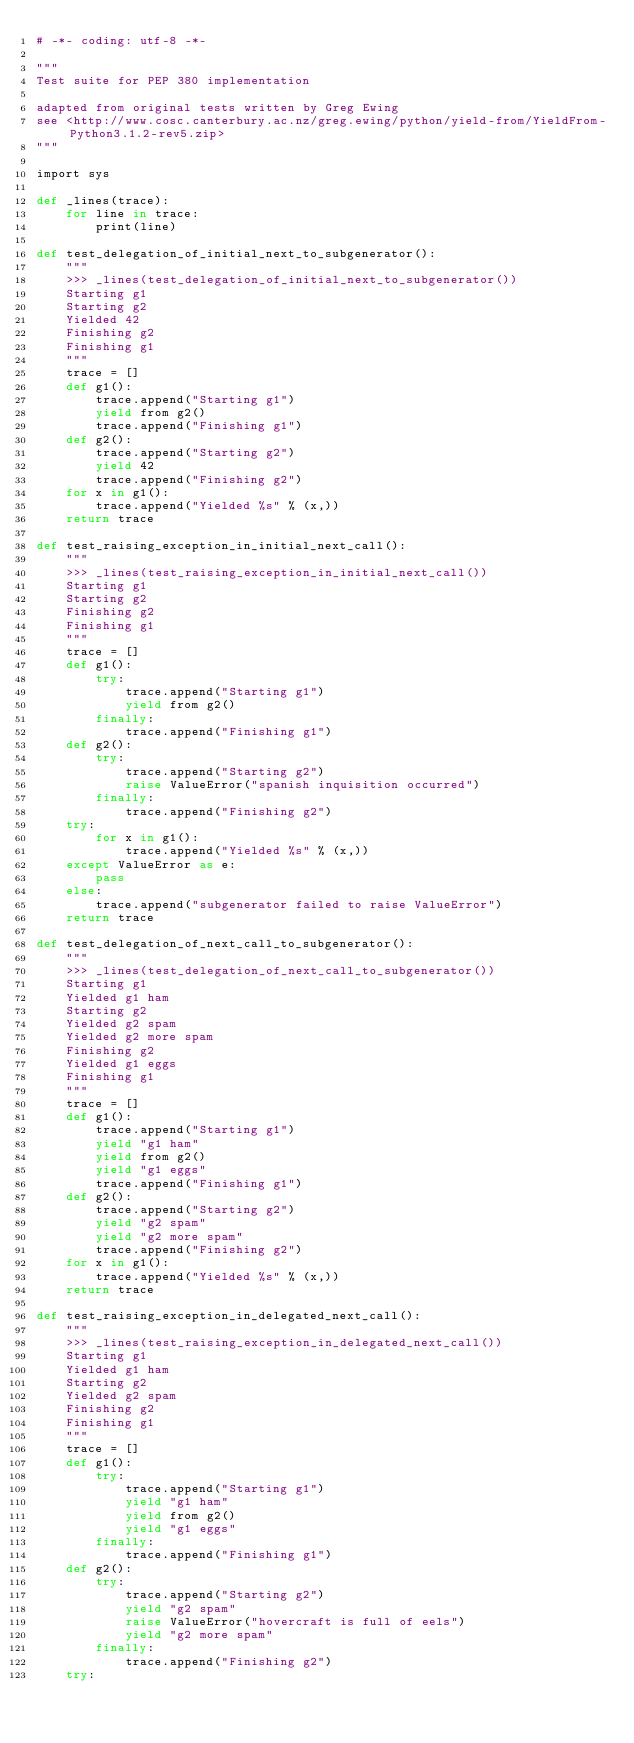Convert code to text. <code><loc_0><loc_0><loc_500><loc_500><_Cython_># -*- coding: utf-8 -*-

"""
Test suite for PEP 380 implementation

adapted from original tests written by Greg Ewing
see <http://www.cosc.canterbury.ac.nz/greg.ewing/python/yield-from/YieldFrom-Python3.1.2-rev5.zip>
"""

import sys

def _lines(trace):
    for line in trace:
        print(line)

def test_delegation_of_initial_next_to_subgenerator():
    """
    >>> _lines(test_delegation_of_initial_next_to_subgenerator())
    Starting g1
    Starting g2
    Yielded 42
    Finishing g2
    Finishing g1
    """
    trace = []
    def g1():
        trace.append("Starting g1")
        yield from g2()
        trace.append("Finishing g1")
    def g2():
        trace.append("Starting g2")
        yield 42
        trace.append("Finishing g2")
    for x in g1():
        trace.append("Yielded %s" % (x,))
    return trace

def test_raising_exception_in_initial_next_call():
    """
    >>> _lines(test_raising_exception_in_initial_next_call())
    Starting g1
    Starting g2
    Finishing g2
    Finishing g1
    """
    trace = []
    def g1():
        try:
            trace.append("Starting g1")
            yield from g2()
        finally:
            trace.append("Finishing g1")
    def g2():
        try:
            trace.append("Starting g2")
            raise ValueError("spanish inquisition occurred")
        finally:
            trace.append("Finishing g2")
    try:
        for x in g1():
            trace.append("Yielded %s" % (x,))
    except ValueError as e:
        pass
    else:
        trace.append("subgenerator failed to raise ValueError")
    return trace

def test_delegation_of_next_call_to_subgenerator():
    """
    >>> _lines(test_delegation_of_next_call_to_subgenerator())
    Starting g1
    Yielded g1 ham
    Starting g2
    Yielded g2 spam
    Yielded g2 more spam
    Finishing g2
    Yielded g1 eggs
    Finishing g1
    """
    trace = []
    def g1():
        trace.append("Starting g1")
        yield "g1 ham"
        yield from g2()
        yield "g1 eggs"
        trace.append("Finishing g1")
    def g2():
        trace.append("Starting g2")
        yield "g2 spam"
        yield "g2 more spam"
        trace.append("Finishing g2")
    for x in g1():
        trace.append("Yielded %s" % (x,))
    return trace

def test_raising_exception_in_delegated_next_call():
    """
    >>> _lines(test_raising_exception_in_delegated_next_call())
    Starting g1
    Yielded g1 ham
    Starting g2
    Yielded g2 spam
    Finishing g2
    Finishing g1
    """
    trace = []
    def g1():
        try:
            trace.append("Starting g1")
            yield "g1 ham"
            yield from g2()
            yield "g1 eggs"
        finally:
            trace.append("Finishing g1")
    def g2():
        try:
            trace.append("Starting g2")
            yield "g2 spam"
            raise ValueError("hovercraft is full of eels")
            yield "g2 more spam"
        finally:
            trace.append("Finishing g2")
    try:</code> 